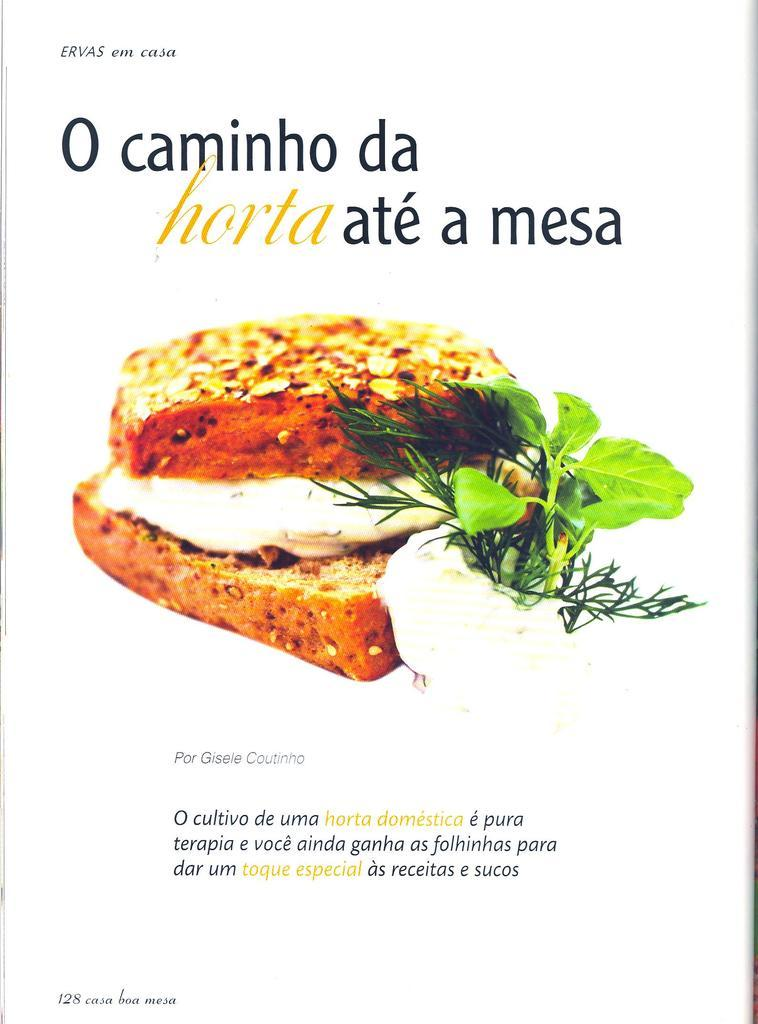What type of visual is the image? The image is a poster. What is the main focus of the poster? There is a snack item and leaves in the center of the poster. What else can be found on the poster? There is text in the background of the poster. How many muscles can be seen in the poster? There are no muscles visible in the poster; it features a snack item, leaves, and text. 